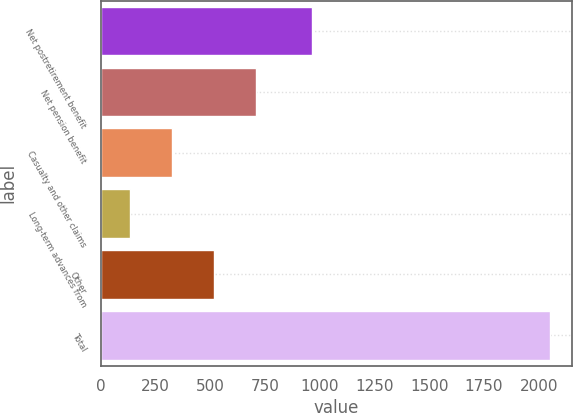Convert chart. <chart><loc_0><loc_0><loc_500><loc_500><bar_chart><fcel>Net postretirement benefit<fcel>Net pension benefit<fcel>Casualty and other claims<fcel>Long-term advances from<fcel>Other<fcel>Total<nl><fcel>964<fcel>708.1<fcel>324.7<fcel>133<fcel>516.4<fcel>2050<nl></chart> 